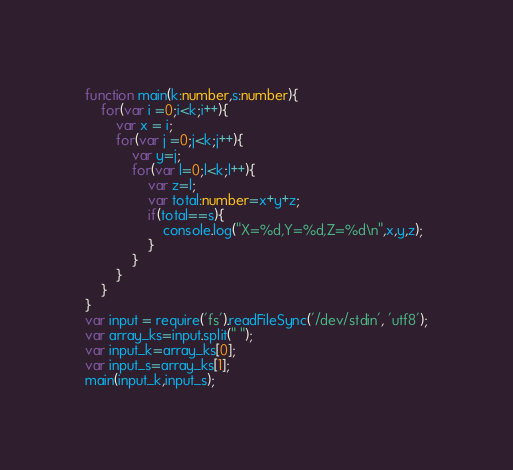<code> <loc_0><loc_0><loc_500><loc_500><_TypeScript_>function main(k:number,s:number){
    for(var i =0;i<k;i++){
        var x = i;
        for(var j =0;j<k;j++){
            var y=j;
            for(var l=0;l<k;l++){
                var z=l;
                var total:number=x+y+z;
                if(total==s){
                    console.log("X=%d,Y=%d,Z=%d\n",x,y,z);
                }
            }
        }
    }
}
var input = require('fs').readFileSync('/dev/stdin', 'utf8');
var array_ks=input.split(" ");
var input_k=array_ks[0];
var input_s=array_ks[1];
main(input_k,input_s);</code> 